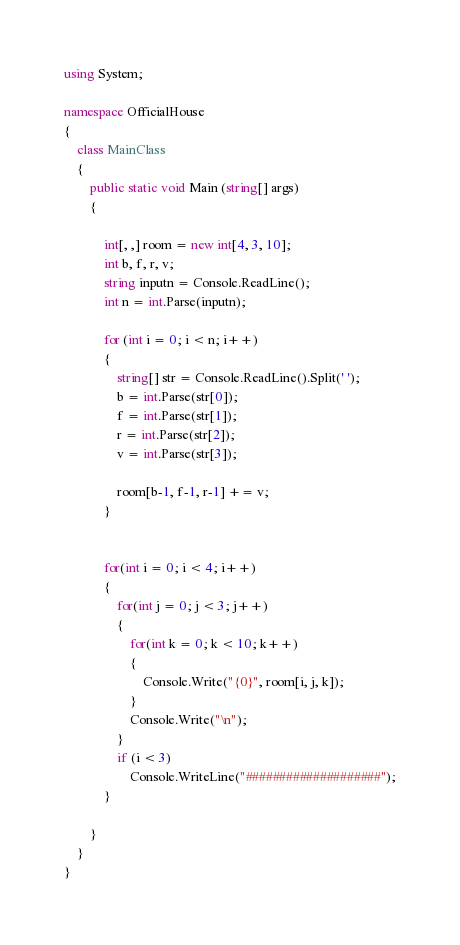Convert code to text. <code><loc_0><loc_0><loc_500><loc_500><_C#_>using System;

namespace OfficialHouse
{
	class MainClass
	{
		public static void Main (string[] args)
		{

			int[, ,] room = new int[4, 3, 10];
			int b, f, r, v;
			string inputn = Console.ReadLine();
			int n = int.Parse(inputn);

			for (int i = 0; i < n; i++)
			{
				string[] str = Console.ReadLine().Split(' ');
				b = int.Parse(str[0]);
				f = int.Parse(str[1]);
				r = int.Parse(str[2]);
				v = int.Parse(str[3]);

				room[b-1, f-1, r-1] += v; 
			}


			for(int i = 0; i < 4; i++)
			{
				for(int j = 0; j < 3; j++)
				{
					for(int k = 0; k < 10; k++)
					{
						Console.Write("{0}", room[i, j, k]);
					}
					Console.Write("\n");
				}
				if (i < 3)
					Console.WriteLine("####################");
			}
		
		}
	}
}</code> 